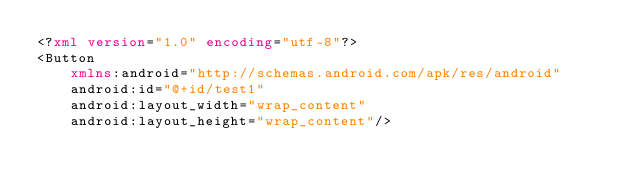<code> <loc_0><loc_0><loc_500><loc_500><_XML_><?xml version="1.0" encoding="utf-8"?>
<Button
    xmlns:android="http://schemas.android.com/apk/res/android"
    android:id="@+id/test1"
    android:layout_width="wrap_content"
    android:layout_height="wrap_content"/></code> 